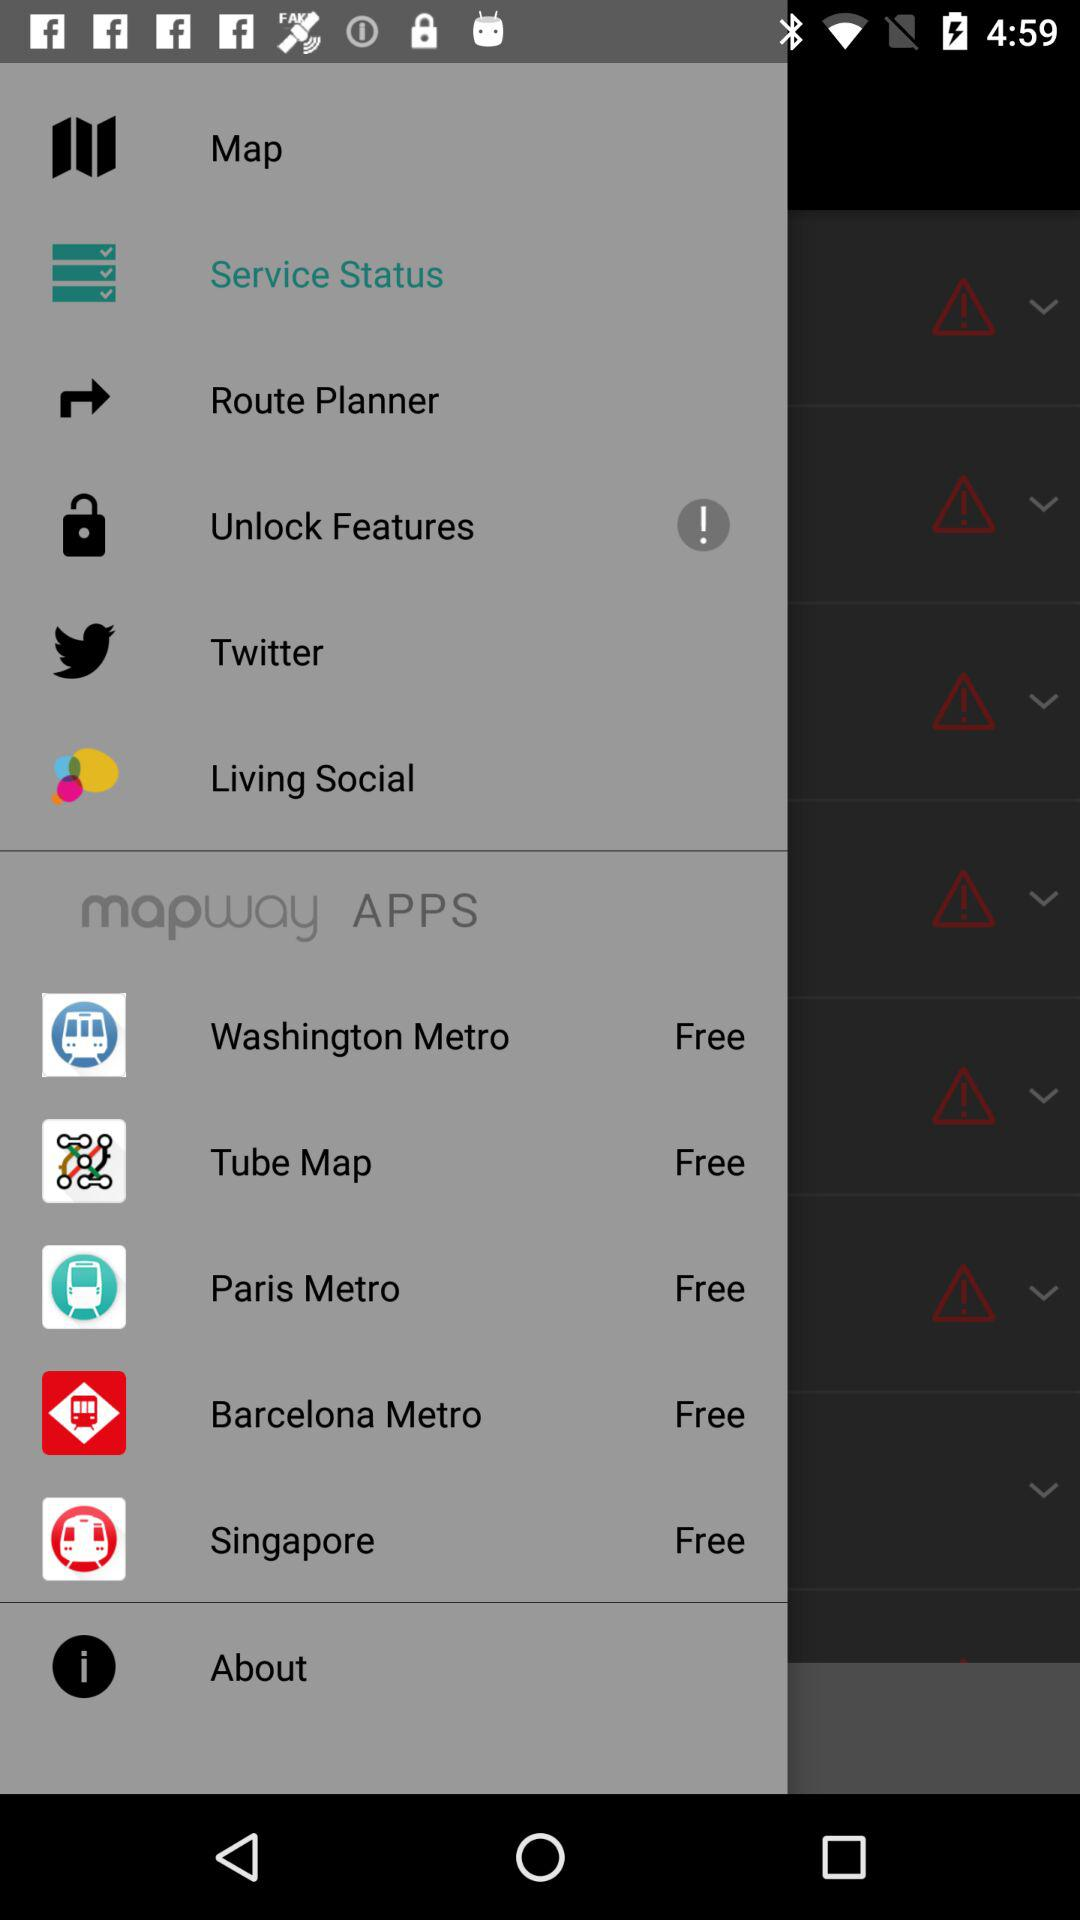How many apps are free?
Answer the question using a single word or phrase. 5 